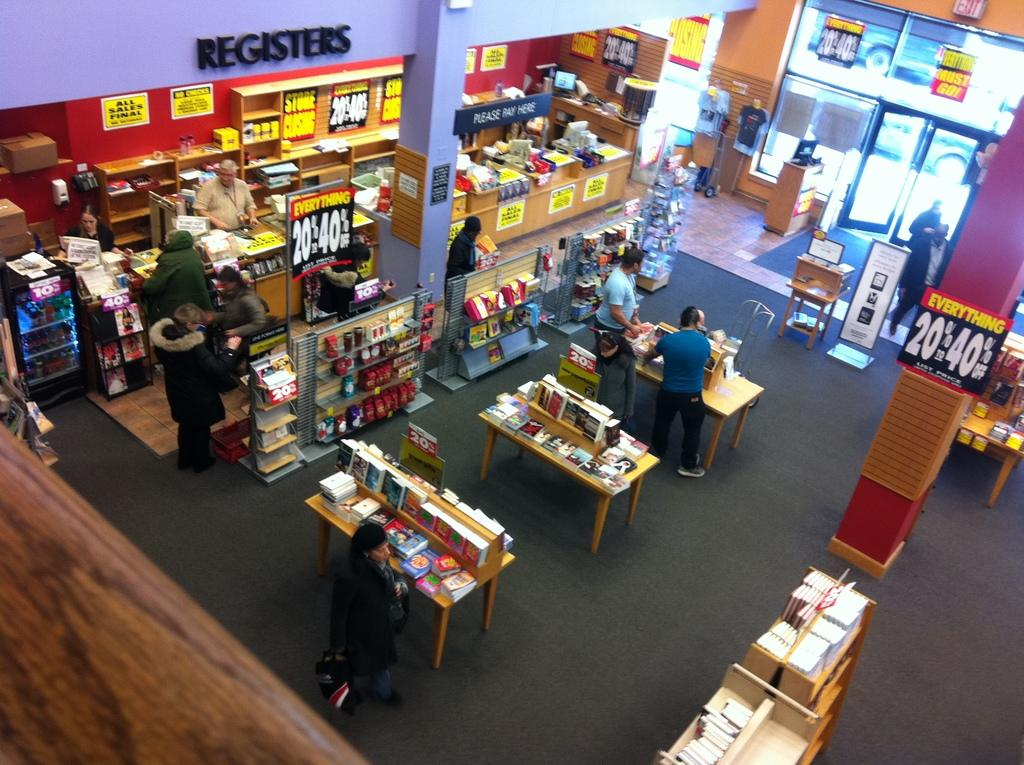<image>
Summarize the visual content of the image. An overhead view of a store with blue walls and the word "Registers" in black letters. 